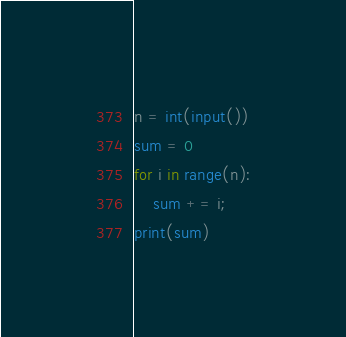<code> <loc_0><loc_0><loc_500><loc_500><_Python_>n = int(input())
sum = 0
for i in range(n):
    sum += i;
print(sum)</code> 